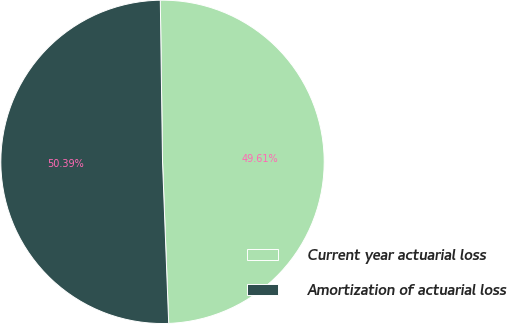Convert chart to OTSL. <chart><loc_0><loc_0><loc_500><loc_500><pie_chart><fcel>Current year actuarial loss<fcel>Amortization of actuarial loss<nl><fcel>49.61%<fcel>50.39%<nl></chart> 